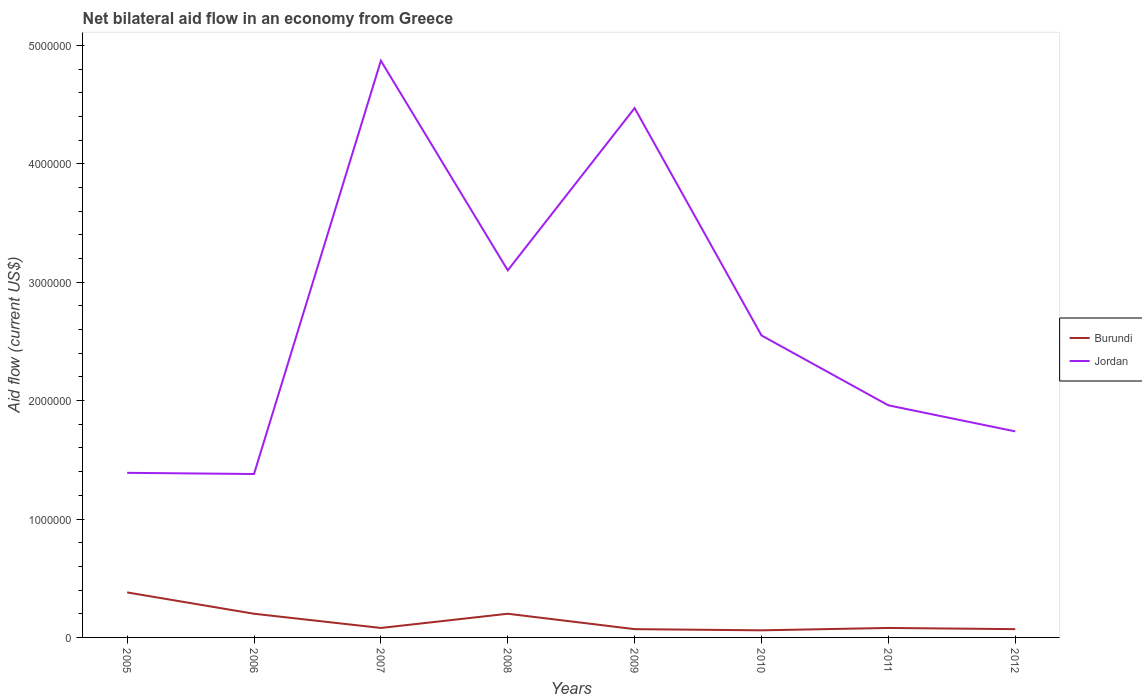How many different coloured lines are there?
Give a very brief answer. 2. Is the number of lines equal to the number of legend labels?
Offer a terse response. Yes. Across all years, what is the maximum net bilateral aid flow in Burundi?
Offer a terse response. 6.00e+04. What is the total net bilateral aid flow in Burundi in the graph?
Provide a short and direct response. 1.40e+05. Does the graph contain any zero values?
Your answer should be compact. No. Where does the legend appear in the graph?
Your response must be concise. Center right. How many legend labels are there?
Keep it short and to the point. 2. What is the title of the graph?
Offer a terse response. Net bilateral aid flow in an economy from Greece. What is the label or title of the X-axis?
Give a very brief answer. Years. What is the label or title of the Y-axis?
Keep it short and to the point. Aid flow (current US$). What is the Aid flow (current US$) of Burundi in 2005?
Offer a very short reply. 3.80e+05. What is the Aid flow (current US$) of Jordan in 2005?
Keep it short and to the point. 1.39e+06. What is the Aid flow (current US$) in Jordan in 2006?
Offer a very short reply. 1.38e+06. What is the Aid flow (current US$) in Burundi in 2007?
Keep it short and to the point. 8.00e+04. What is the Aid flow (current US$) of Jordan in 2007?
Give a very brief answer. 4.87e+06. What is the Aid flow (current US$) in Jordan in 2008?
Offer a very short reply. 3.10e+06. What is the Aid flow (current US$) of Jordan in 2009?
Provide a succinct answer. 4.47e+06. What is the Aid flow (current US$) of Burundi in 2010?
Give a very brief answer. 6.00e+04. What is the Aid flow (current US$) in Jordan in 2010?
Your answer should be very brief. 2.55e+06. What is the Aid flow (current US$) in Burundi in 2011?
Ensure brevity in your answer.  8.00e+04. What is the Aid flow (current US$) in Jordan in 2011?
Your response must be concise. 1.96e+06. What is the Aid flow (current US$) of Jordan in 2012?
Keep it short and to the point. 1.74e+06. Across all years, what is the maximum Aid flow (current US$) of Burundi?
Your answer should be compact. 3.80e+05. Across all years, what is the maximum Aid flow (current US$) in Jordan?
Provide a short and direct response. 4.87e+06. Across all years, what is the minimum Aid flow (current US$) of Jordan?
Keep it short and to the point. 1.38e+06. What is the total Aid flow (current US$) of Burundi in the graph?
Your response must be concise. 1.14e+06. What is the total Aid flow (current US$) in Jordan in the graph?
Ensure brevity in your answer.  2.15e+07. What is the difference between the Aid flow (current US$) of Jordan in 2005 and that in 2007?
Offer a terse response. -3.48e+06. What is the difference between the Aid flow (current US$) in Burundi in 2005 and that in 2008?
Give a very brief answer. 1.80e+05. What is the difference between the Aid flow (current US$) of Jordan in 2005 and that in 2008?
Offer a very short reply. -1.71e+06. What is the difference between the Aid flow (current US$) in Burundi in 2005 and that in 2009?
Offer a terse response. 3.10e+05. What is the difference between the Aid flow (current US$) of Jordan in 2005 and that in 2009?
Your response must be concise. -3.08e+06. What is the difference between the Aid flow (current US$) in Jordan in 2005 and that in 2010?
Your answer should be very brief. -1.16e+06. What is the difference between the Aid flow (current US$) of Burundi in 2005 and that in 2011?
Ensure brevity in your answer.  3.00e+05. What is the difference between the Aid flow (current US$) in Jordan in 2005 and that in 2011?
Offer a very short reply. -5.70e+05. What is the difference between the Aid flow (current US$) in Burundi in 2005 and that in 2012?
Offer a terse response. 3.10e+05. What is the difference between the Aid flow (current US$) in Jordan in 2005 and that in 2012?
Make the answer very short. -3.50e+05. What is the difference between the Aid flow (current US$) in Jordan in 2006 and that in 2007?
Your answer should be compact. -3.49e+06. What is the difference between the Aid flow (current US$) of Jordan in 2006 and that in 2008?
Offer a terse response. -1.72e+06. What is the difference between the Aid flow (current US$) in Burundi in 2006 and that in 2009?
Offer a very short reply. 1.30e+05. What is the difference between the Aid flow (current US$) of Jordan in 2006 and that in 2009?
Keep it short and to the point. -3.09e+06. What is the difference between the Aid flow (current US$) in Burundi in 2006 and that in 2010?
Offer a very short reply. 1.40e+05. What is the difference between the Aid flow (current US$) in Jordan in 2006 and that in 2010?
Ensure brevity in your answer.  -1.17e+06. What is the difference between the Aid flow (current US$) of Burundi in 2006 and that in 2011?
Make the answer very short. 1.20e+05. What is the difference between the Aid flow (current US$) in Jordan in 2006 and that in 2011?
Provide a short and direct response. -5.80e+05. What is the difference between the Aid flow (current US$) of Jordan in 2006 and that in 2012?
Keep it short and to the point. -3.60e+05. What is the difference between the Aid flow (current US$) in Jordan in 2007 and that in 2008?
Give a very brief answer. 1.77e+06. What is the difference between the Aid flow (current US$) of Jordan in 2007 and that in 2009?
Ensure brevity in your answer.  4.00e+05. What is the difference between the Aid flow (current US$) of Jordan in 2007 and that in 2010?
Your answer should be very brief. 2.32e+06. What is the difference between the Aid flow (current US$) of Burundi in 2007 and that in 2011?
Make the answer very short. 0. What is the difference between the Aid flow (current US$) in Jordan in 2007 and that in 2011?
Make the answer very short. 2.91e+06. What is the difference between the Aid flow (current US$) in Jordan in 2007 and that in 2012?
Offer a very short reply. 3.13e+06. What is the difference between the Aid flow (current US$) of Burundi in 2008 and that in 2009?
Provide a short and direct response. 1.30e+05. What is the difference between the Aid flow (current US$) of Jordan in 2008 and that in 2009?
Keep it short and to the point. -1.37e+06. What is the difference between the Aid flow (current US$) in Burundi in 2008 and that in 2010?
Ensure brevity in your answer.  1.40e+05. What is the difference between the Aid flow (current US$) in Burundi in 2008 and that in 2011?
Your answer should be very brief. 1.20e+05. What is the difference between the Aid flow (current US$) of Jordan in 2008 and that in 2011?
Provide a succinct answer. 1.14e+06. What is the difference between the Aid flow (current US$) of Burundi in 2008 and that in 2012?
Offer a terse response. 1.30e+05. What is the difference between the Aid flow (current US$) of Jordan in 2008 and that in 2012?
Offer a terse response. 1.36e+06. What is the difference between the Aid flow (current US$) in Burundi in 2009 and that in 2010?
Your answer should be compact. 10000. What is the difference between the Aid flow (current US$) in Jordan in 2009 and that in 2010?
Give a very brief answer. 1.92e+06. What is the difference between the Aid flow (current US$) of Burundi in 2009 and that in 2011?
Give a very brief answer. -10000. What is the difference between the Aid flow (current US$) in Jordan in 2009 and that in 2011?
Make the answer very short. 2.51e+06. What is the difference between the Aid flow (current US$) in Burundi in 2009 and that in 2012?
Make the answer very short. 0. What is the difference between the Aid flow (current US$) in Jordan in 2009 and that in 2012?
Keep it short and to the point. 2.73e+06. What is the difference between the Aid flow (current US$) in Jordan in 2010 and that in 2011?
Your response must be concise. 5.90e+05. What is the difference between the Aid flow (current US$) in Burundi in 2010 and that in 2012?
Your answer should be very brief. -10000. What is the difference between the Aid flow (current US$) in Jordan in 2010 and that in 2012?
Provide a short and direct response. 8.10e+05. What is the difference between the Aid flow (current US$) of Burundi in 2011 and that in 2012?
Provide a short and direct response. 10000. What is the difference between the Aid flow (current US$) of Jordan in 2011 and that in 2012?
Your answer should be very brief. 2.20e+05. What is the difference between the Aid flow (current US$) of Burundi in 2005 and the Aid flow (current US$) of Jordan in 2007?
Offer a terse response. -4.49e+06. What is the difference between the Aid flow (current US$) of Burundi in 2005 and the Aid flow (current US$) of Jordan in 2008?
Your answer should be compact. -2.72e+06. What is the difference between the Aid flow (current US$) of Burundi in 2005 and the Aid flow (current US$) of Jordan in 2009?
Your response must be concise. -4.09e+06. What is the difference between the Aid flow (current US$) in Burundi in 2005 and the Aid flow (current US$) in Jordan in 2010?
Offer a very short reply. -2.17e+06. What is the difference between the Aid flow (current US$) of Burundi in 2005 and the Aid flow (current US$) of Jordan in 2011?
Provide a short and direct response. -1.58e+06. What is the difference between the Aid flow (current US$) in Burundi in 2005 and the Aid flow (current US$) in Jordan in 2012?
Make the answer very short. -1.36e+06. What is the difference between the Aid flow (current US$) in Burundi in 2006 and the Aid flow (current US$) in Jordan in 2007?
Offer a very short reply. -4.67e+06. What is the difference between the Aid flow (current US$) in Burundi in 2006 and the Aid flow (current US$) in Jordan in 2008?
Your response must be concise. -2.90e+06. What is the difference between the Aid flow (current US$) in Burundi in 2006 and the Aid flow (current US$) in Jordan in 2009?
Offer a terse response. -4.27e+06. What is the difference between the Aid flow (current US$) of Burundi in 2006 and the Aid flow (current US$) of Jordan in 2010?
Make the answer very short. -2.35e+06. What is the difference between the Aid flow (current US$) of Burundi in 2006 and the Aid flow (current US$) of Jordan in 2011?
Provide a short and direct response. -1.76e+06. What is the difference between the Aid flow (current US$) in Burundi in 2006 and the Aid flow (current US$) in Jordan in 2012?
Offer a very short reply. -1.54e+06. What is the difference between the Aid flow (current US$) in Burundi in 2007 and the Aid flow (current US$) in Jordan in 2008?
Your answer should be very brief. -3.02e+06. What is the difference between the Aid flow (current US$) of Burundi in 2007 and the Aid flow (current US$) of Jordan in 2009?
Your answer should be compact. -4.39e+06. What is the difference between the Aid flow (current US$) in Burundi in 2007 and the Aid flow (current US$) in Jordan in 2010?
Provide a short and direct response. -2.47e+06. What is the difference between the Aid flow (current US$) of Burundi in 2007 and the Aid flow (current US$) of Jordan in 2011?
Provide a short and direct response. -1.88e+06. What is the difference between the Aid flow (current US$) of Burundi in 2007 and the Aid flow (current US$) of Jordan in 2012?
Your answer should be very brief. -1.66e+06. What is the difference between the Aid flow (current US$) in Burundi in 2008 and the Aid flow (current US$) in Jordan in 2009?
Offer a very short reply. -4.27e+06. What is the difference between the Aid flow (current US$) in Burundi in 2008 and the Aid flow (current US$) in Jordan in 2010?
Make the answer very short. -2.35e+06. What is the difference between the Aid flow (current US$) of Burundi in 2008 and the Aid flow (current US$) of Jordan in 2011?
Your response must be concise. -1.76e+06. What is the difference between the Aid flow (current US$) in Burundi in 2008 and the Aid flow (current US$) in Jordan in 2012?
Provide a succinct answer. -1.54e+06. What is the difference between the Aid flow (current US$) in Burundi in 2009 and the Aid flow (current US$) in Jordan in 2010?
Provide a short and direct response. -2.48e+06. What is the difference between the Aid flow (current US$) in Burundi in 2009 and the Aid flow (current US$) in Jordan in 2011?
Offer a terse response. -1.89e+06. What is the difference between the Aid flow (current US$) of Burundi in 2009 and the Aid flow (current US$) of Jordan in 2012?
Your answer should be compact. -1.67e+06. What is the difference between the Aid flow (current US$) of Burundi in 2010 and the Aid flow (current US$) of Jordan in 2011?
Ensure brevity in your answer.  -1.90e+06. What is the difference between the Aid flow (current US$) in Burundi in 2010 and the Aid flow (current US$) in Jordan in 2012?
Your response must be concise. -1.68e+06. What is the difference between the Aid flow (current US$) of Burundi in 2011 and the Aid flow (current US$) of Jordan in 2012?
Give a very brief answer. -1.66e+06. What is the average Aid flow (current US$) in Burundi per year?
Provide a short and direct response. 1.42e+05. What is the average Aid flow (current US$) in Jordan per year?
Your answer should be compact. 2.68e+06. In the year 2005, what is the difference between the Aid flow (current US$) in Burundi and Aid flow (current US$) in Jordan?
Offer a very short reply. -1.01e+06. In the year 2006, what is the difference between the Aid flow (current US$) in Burundi and Aid flow (current US$) in Jordan?
Your answer should be very brief. -1.18e+06. In the year 2007, what is the difference between the Aid flow (current US$) of Burundi and Aid flow (current US$) of Jordan?
Your answer should be very brief. -4.79e+06. In the year 2008, what is the difference between the Aid flow (current US$) of Burundi and Aid flow (current US$) of Jordan?
Your answer should be very brief. -2.90e+06. In the year 2009, what is the difference between the Aid flow (current US$) in Burundi and Aid flow (current US$) in Jordan?
Give a very brief answer. -4.40e+06. In the year 2010, what is the difference between the Aid flow (current US$) in Burundi and Aid flow (current US$) in Jordan?
Your answer should be very brief. -2.49e+06. In the year 2011, what is the difference between the Aid flow (current US$) in Burundi and Aid flow (current US$) in Jordan?
Make the answer very short. -1.88e+06. In the year 2012, what is the difference between the Aid flow (current US$) of Burundi and Aid flow (current US$) of Jordan?
Keep it short and to the point. -1.67e+06. What is the ratio of the Aid flow (current US$) of Burundi in 2005 to that in 2006?
Offer a terse response. 1.9. What is the ratio of the Aid flow (current US$) in Jordan in 2005 to that in 2006?
Your answer should be compact. 1.01. What is the ratio of the Aid flow (current US$) in Burundi in 2005 to that in 2007?
Provide a succinct answer. 4.75. What is the ratio of the Aid flow (current US$) of Jordan in 2005 to that in 2007?
Keep it short and to the point. 0.29. What is the ratio of the Aid flow (current US$) of Burundi in 2005 to that in 2008?
Make the answer very short. 1.9. What is the ratio of the Aid flow (current US$) in Jordan in 2005 to that in 2008?
Offer a very short reply. 0.45. What is the ratio of the Aid flow (current US$) of Burundi in 2005 to that in 2009?
Provide a short and direct response. 5.43. What is the ratio of the Aid flow (current US$) of Jordan in 2005 to that in 2009?
Offer a very short reply. 0.31. What is the ratio of the Aid flow (current US$) of Burundi in 2005 to that in 2010?
Ensure brevity in your answer.  6.33. What is the ratio of the Aid flow (current US$) of Jordan in 2005 to that in 2010?
Provide a short and direct response. 0.55. What is the ratio of the Aid flow (current US$) of Burundi in 2005 to that in 2011?
Offer a very short reply. 4.75. What is the ratio of the Aid flow (current US$) in Jordan in 2005 to that in 2011?
Offer a terse response. 0.71. What is the ratio of the Aid flow (current US$) in Burundi in 2005 to that in 2012?
Provide a succinct answer. 5.43. What is the ratio of the Aid flow (current US$) in Jordan in 2005 to that in 2012?
Keep it short and to the point. 0.8. What is the ratio of the Aid flow (current US$) in Burundi in 2006 to that in 2007?
Your answer should be compact. 2.5. What is the ratio of the Aid flow (current US$) in Jordan in 2006 to that in 2007?
Provide a succinct answer. 0.28. What is the ratio of the Aid flow (current US$) of Burundi in 2006 to that in 2008?
Provide a succinct answer. 1. What is the ratio of the Aid flow (current US$) in Jordan in 2006 to that in 2008?
Make the answer very short. 0.45. What is the ratio of the Aid flow (current US$) in Burundi in 2006 to that in 2009?
Your answer should be very brief. 2.86. What is the ratio of the Aid flow (current US$) of Jordan in 2006 to that in 2009?
Provide a short and direct response. 0.31. What is the ratio of the Aid flow (current US$) in Burundi in 2006 to that in 2010?
Provide a succinct answer. 3.33. What is the ratio of the Aid flow (current US$) of Jordan in 2006 to that in 2010?
Your response must be concise. 0.54. What is the ratio of the Aid flow (current US$) of Jordan in 2006 to that in 2011?
Offer a terse response. 0.7. What is the ratio of the Aid flow (current US$) in Burundi in 2006 to that in 2012?
Your answer should be compact. 2.86. What is the ratio of the Aid flow (current US$) of Jordan in 2006 to that in 2012?
Give a very brief answer. 0.79. What is the ratio of the Aid flow (current US$) of Jordan in 2007 to that in 2008?
Provide a short and direct response. 1.57. What is the ratio of the Aid flow (current US$) in Burundi in 2007 to that in 2009?
Your response must be concise. 1.14. What is the ratio of the Aid flow (current US$) of Jordan in 2007 to that in 2009?
Make the answer very short. 1.09. What is the ratio of the Aid flow (current US$) of Burundi in 2007 to that in 2010?
Give a very brief answer. 1.33. What is the ratio of the Aid flow (current US$) in Jordan in 2007 to that in 2010?
Your answer should be compact. 1.91. What is the ratio of the Aid flow (current US$) of Jordan in 2007 to that in 2011?
Your answer should be very brief. 2.48. What is the ratio of the Aid flow (current US$) in Burundi in 2007 to that in 2012?
Your answer should be very brief. 1.14. What is the ratio of the Aid flow (current US$) in Jordan in 2007 to that in 2012?
Give a very brief answer. 2.8. What is the ratio of the Aid flow (current US$) in Burundi in 2008 to that in 2009?
Offer a very short reply. 2.86. What is the ratio of the Aid flow (current US$) in Jordan in 2008 to that in 2009?
Offer a very short reply. 0.69. What is the ratio of the Aid flow (current US$) in Burundi in 2008 to that in 2010?
Ensure brevity in your answer.  3.33. What is the ratio of the Aid flow (current US$) in Jordan in 2008 to that in 2010?
Offer a very short reply. 1.22. What is the ratio of the Aid flow (current US$) in Burundi in 2008 to that in 2011?
Make the answer very short. 2.5. What is the ratio of the Aid flow (current US$) in Jordan in 2008 to that in 2011?
Keep it short and to the point. 1.58. What is the ratio of the Aid flow (current US$) in Burundi in 2008 to that in 2012?
Make the answer very short. 2.86. What is the ratio of the Aid flow (current US$) in Jordan in 2008 to that in 2012?
Your response must be concise. 1.78. What is the ratio of the Aid flow (current US$) of Jordan in 2009 to that in 2010?
Provide a succinct answer. 1.75. What is the ratio of the Aid flow (current US$) of Burundi in 2009 to that in 2011?
Keep it short and to the point. 0.88. What is the ratio of the Aid flow (current US$) in Jordan in 2009 to that in 2011?
Your answer should be very brief. 2.28. What is the ratio of the Aid flow (current US$) of Burundi in 2009 to that in 2012?
Offer a terse response. 1. What is the ratio of the Aid flow (current US$) of Jordan in 2009 to that in 2012?
Make the answer very short. 2.57. What is the ratio of the Aid flow (current US$) of Jordan in 2010 to that in 2011?
Your response must be concise. 1.3. What is the ratio of the Aid flow (current US$) of Jordan in 2010 to that in 2012?
Offer a very short reply. 1.47. What is the ratio of the Aid flow (current US$) in Burundi in 2011 to that in 2012?
Give a very brief answer. 1.14. What is the ratio of the Aid flow (current US$) of Jordan in 2011 to that in 2012?
Ensure brevity in your answer.  1.13. What is the difference between the highest and the second highest Aid flow (current US$) of Jordan?
Keep it short and to the point. 4.00e+05. What is the difference between the highest and the lowest Aid flow (current US$) of Jordan?
Provide a short and direct response. 3.49e+06. 